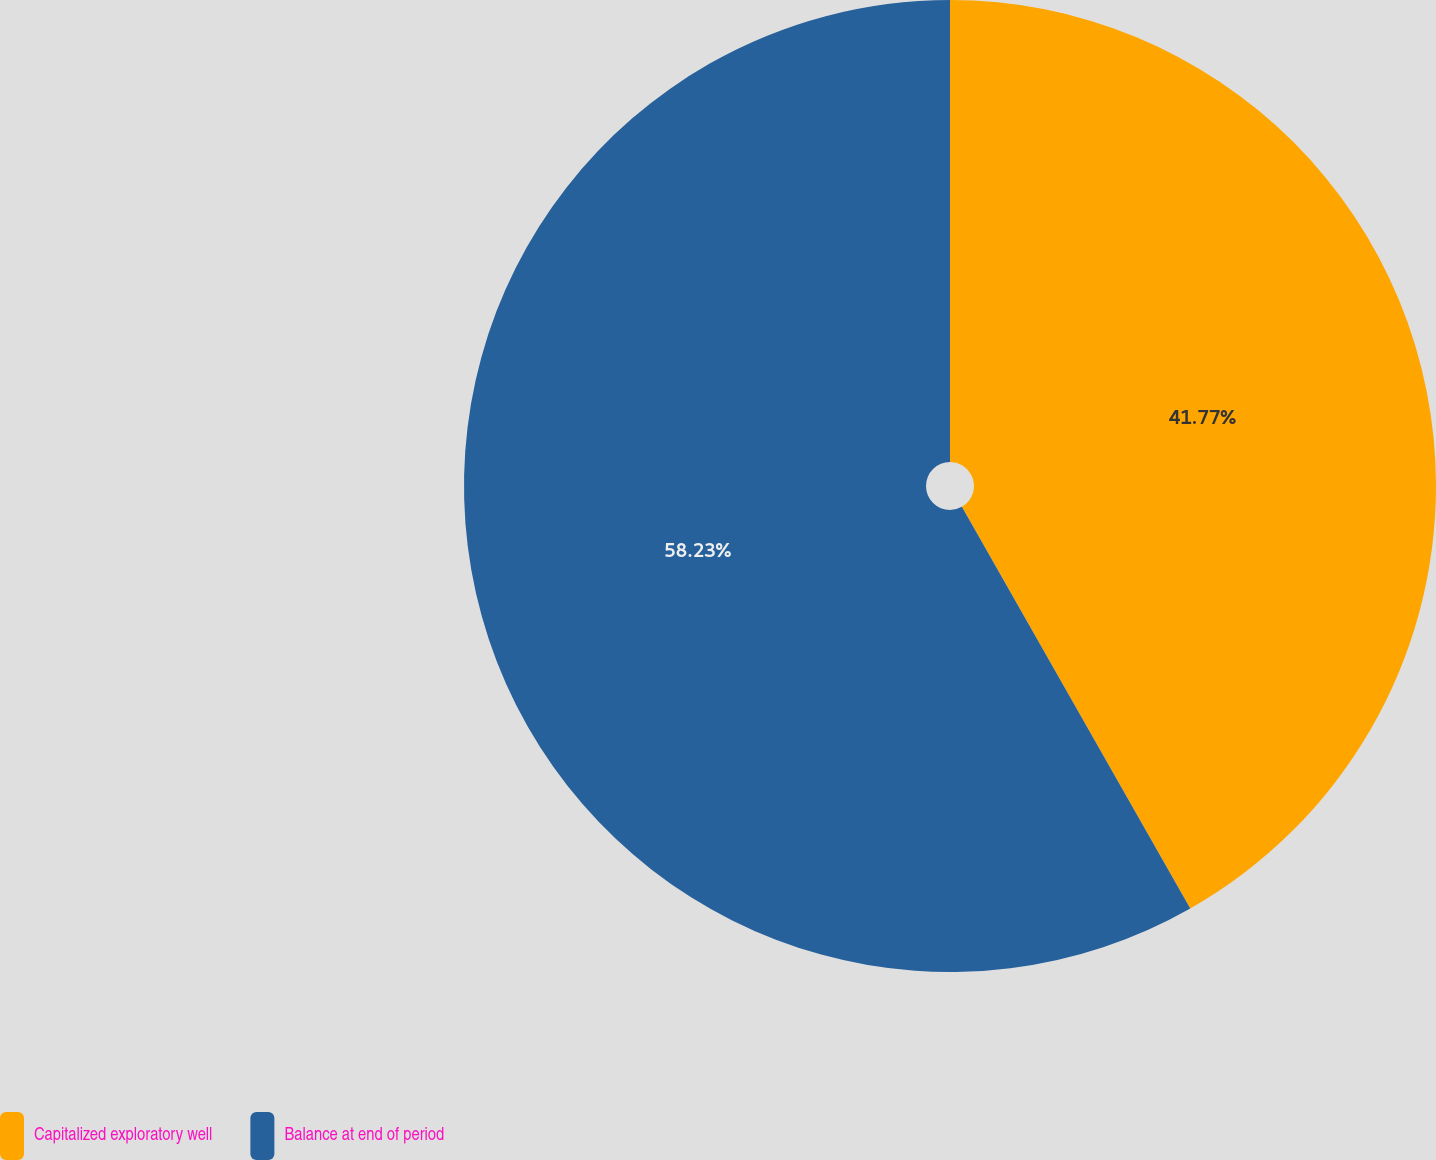<chart> <loc_0><loc_0><loc_500><loc_500><pie_chart><fcel>Capitalized exploratory well<fcel>Balance at end of period<nl><fcel>41.77%<fcel>58.23%<nl></chart> 